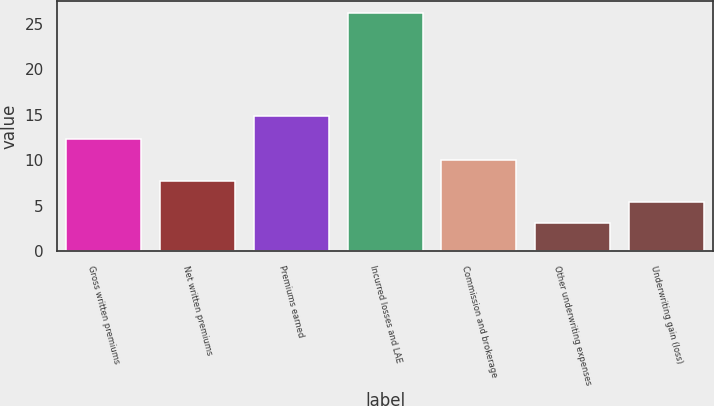Convert chart to OTSL. <chart><loc_0><loc_0><loc_500><loc_500><bar_chart><fcel>Gross written premiums<fcel>Net written premiums<fcel>Premiums earned<fcel>Incurred losses and LAE<fcel>Commission and brokerage<fcel>Other underwriting expenses<fcel>Underwriting gain (loss)<nl><fcel>12.34<fcel>7.72<fcel>14.9<fcel>26.2<fcel>10.03<fcel>3.1<fcel>5.41<nl></chart> 